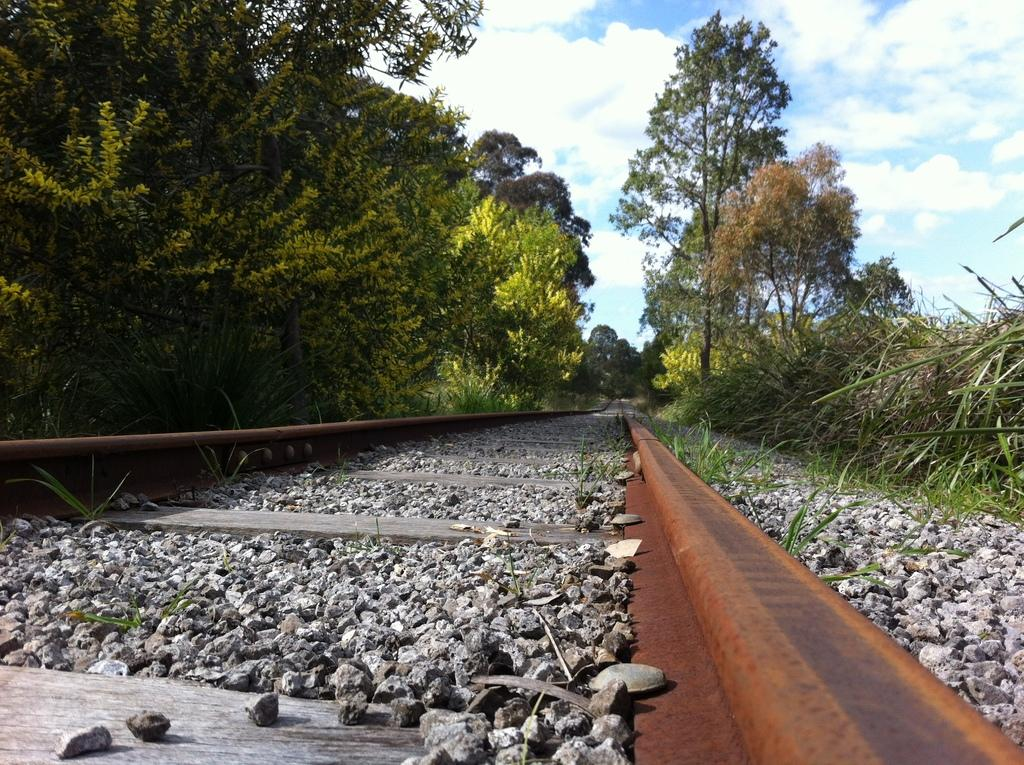What type of transportation infrastructure is visible in the image? There are train tracks in the image. What type of natural elements can be seen in the image? There are stones, plants, trees, and clouds visible in the image. Can you describe the background of the image? The background of the image includes plants, trees, and clouds. What type of baseball grip is being demonstrated in the image? There is no baseball or any indication of a grip being demonstrated in the image. 